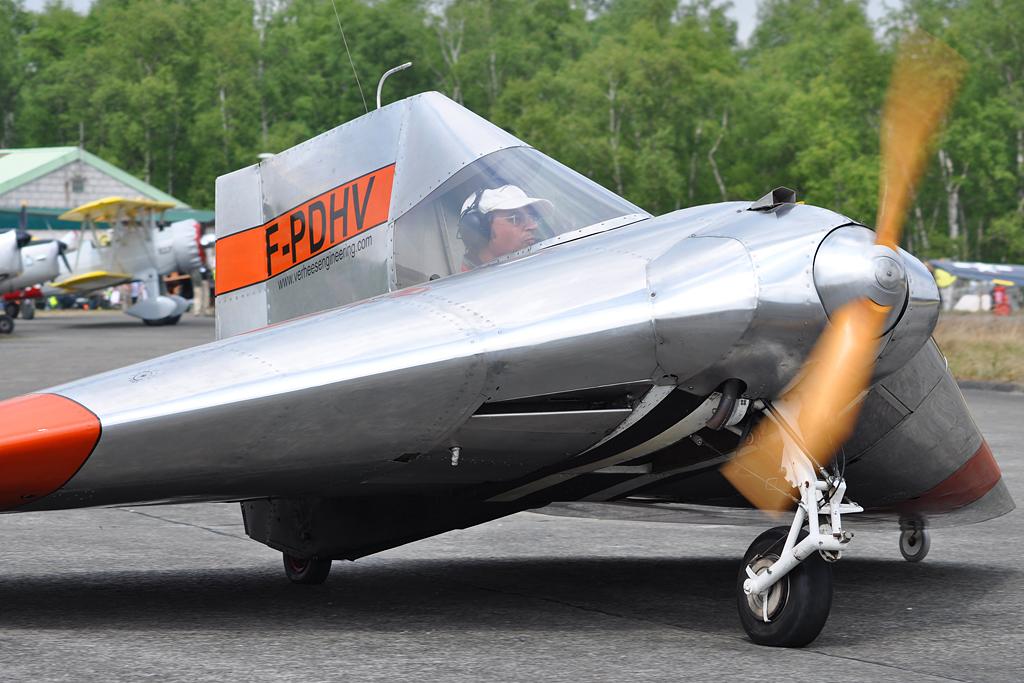What letters are on the craft?
Offer a terse response. F-pdhv. What website is labeled on the plane?
Your answer should be very brief. Www.verheesengineering.com. 